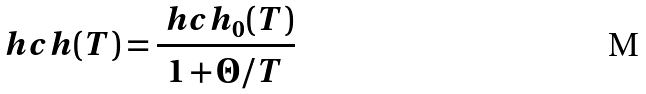Convert formula to latex. <formula><loc_0><loc_0><loc_500><loc_500>\ h c h ( T ) = \frac { \ h c h _ { 0 } ( T ) } { 1 + \Theta / T }</formula> 